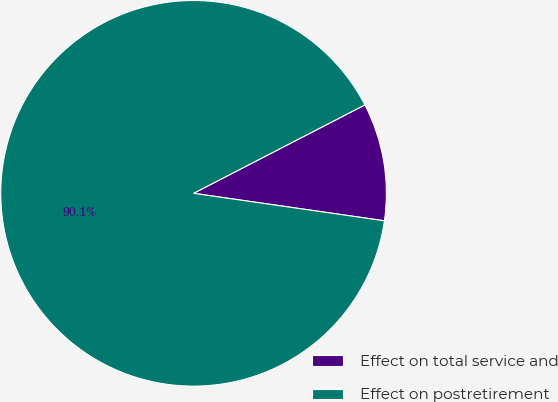Convert chart. <chart><loc_0><loc_0><loc_500><loc_500><pie_chart><fcel>Effect on total service and<fcel>Effect on postretirement<nl><fcel>9.86%<fcel>90.14%<nl></chart> 